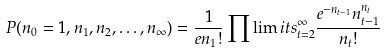Convert formula to latex. <formula><loc_0><loc_0><loc_500><loc_500>P ( n _ { 0 } = 1 , n _ { 1 } , n _ { 2 } , \dots , n _ { \infty } ) = \frac { 1 } { e n _ { 1 } ! } \prod \lim i t s ^ { \infty } _ { t = 2 } \frac { e ^ { - n _ { t - 1 } } n ^ { n _ { t } } _ { t - 1 } } { n _ { t } ! }</formula> 